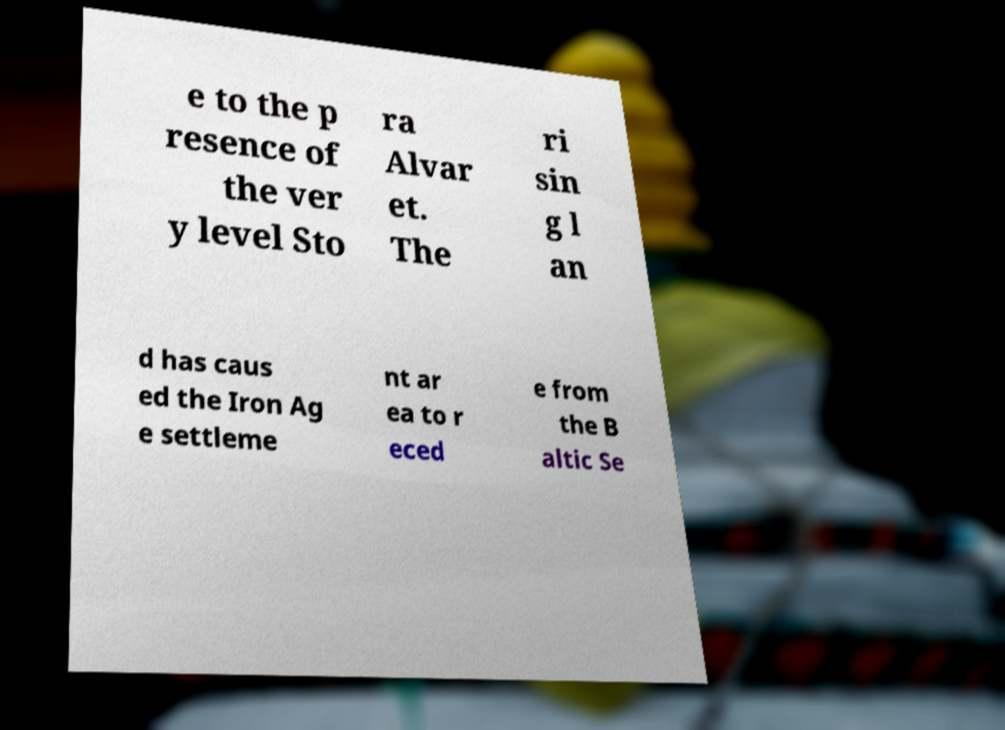Please identify and transcribe the text found in this image. e to the p resence of the ver y level Sto ra Alvar et. The ri sin g l an d has caus ed the Iron Ag e settleme nt ar ea to r eced e from the B altic Se 